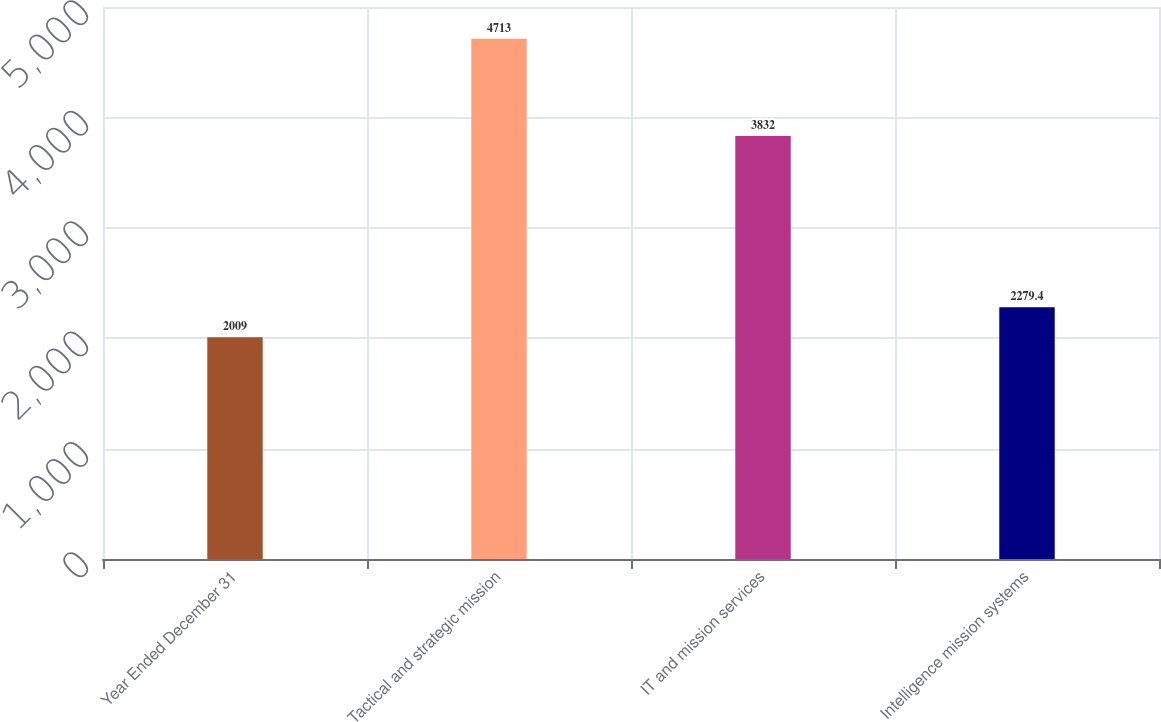Convert chart. <chart><loc_0><loc_0><loc_500><loc_500><bar_chart><fcel>Year Ended December 31<fcel>Tactical and strategic mission<fcel>IT and mission services<fcel>Intelligence mission systems<nl><fcel>2009<fcel>4713<fcel>3832<fcel>2279.4<nl></chart> 